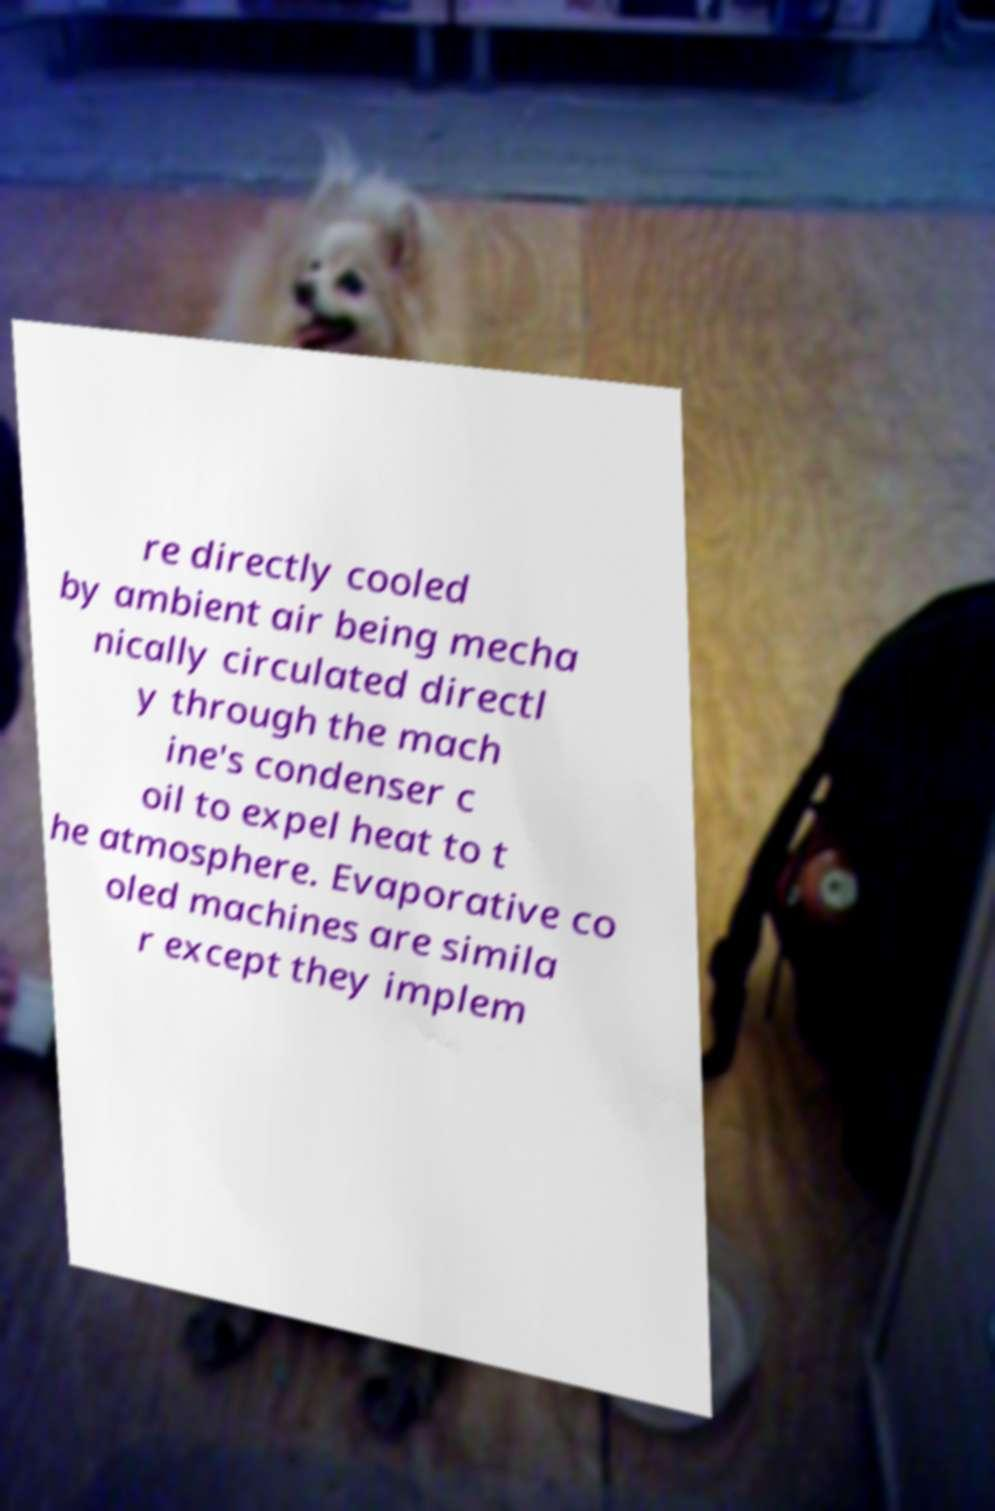Could you assist in decoding the text presented in this image and type it out clearly? re directly cooled by ambient air being mecha nically circulated directl y through the mach ine's condenser c oil to expel heat to t he atmosphere. Evaporative co oled machines are simila r except they implem 